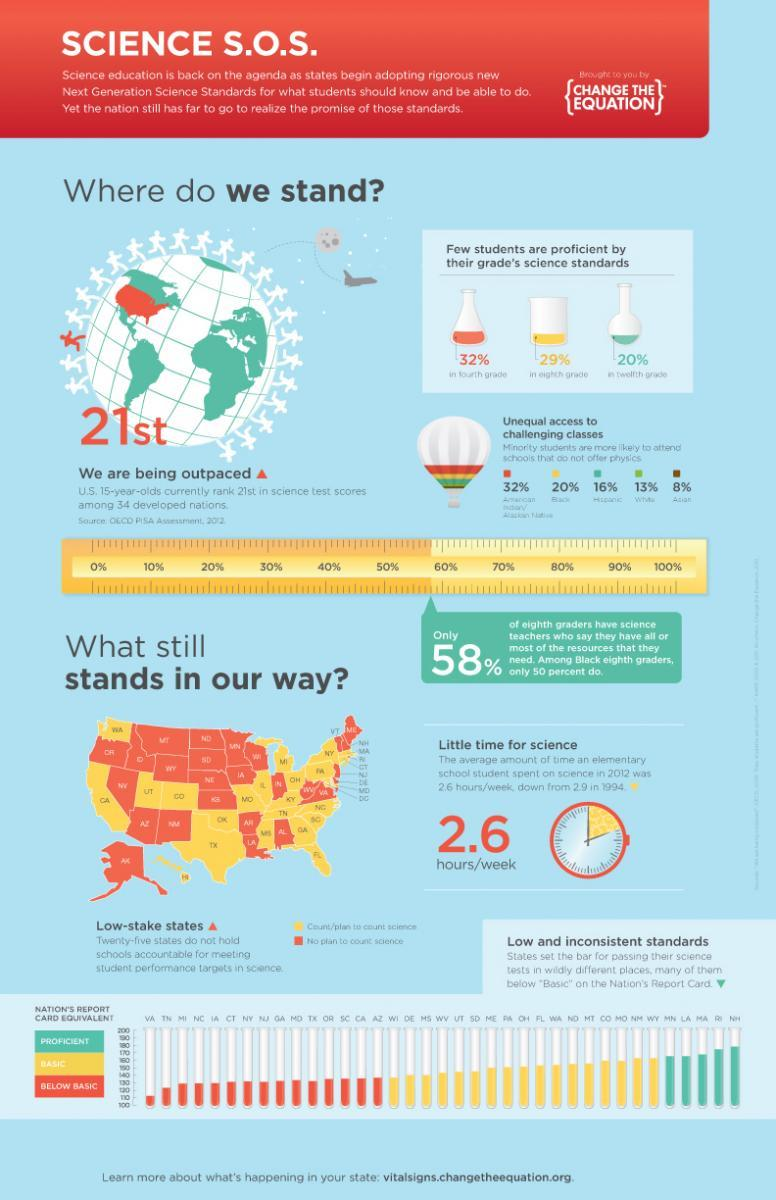Mention a couple of crucial points in this snapshot. In the United States, only 20% of students are proficient in the science standards for their twelfth grade. A significant percentage of black students in America are more likely to attend schools that do not offer physics. According to a recent study, approximately 8% of Asian students in America are more likely to attend schools that do not offer physics. In the United States, only 29% of eighth-grade students are proficient in their science standards. 